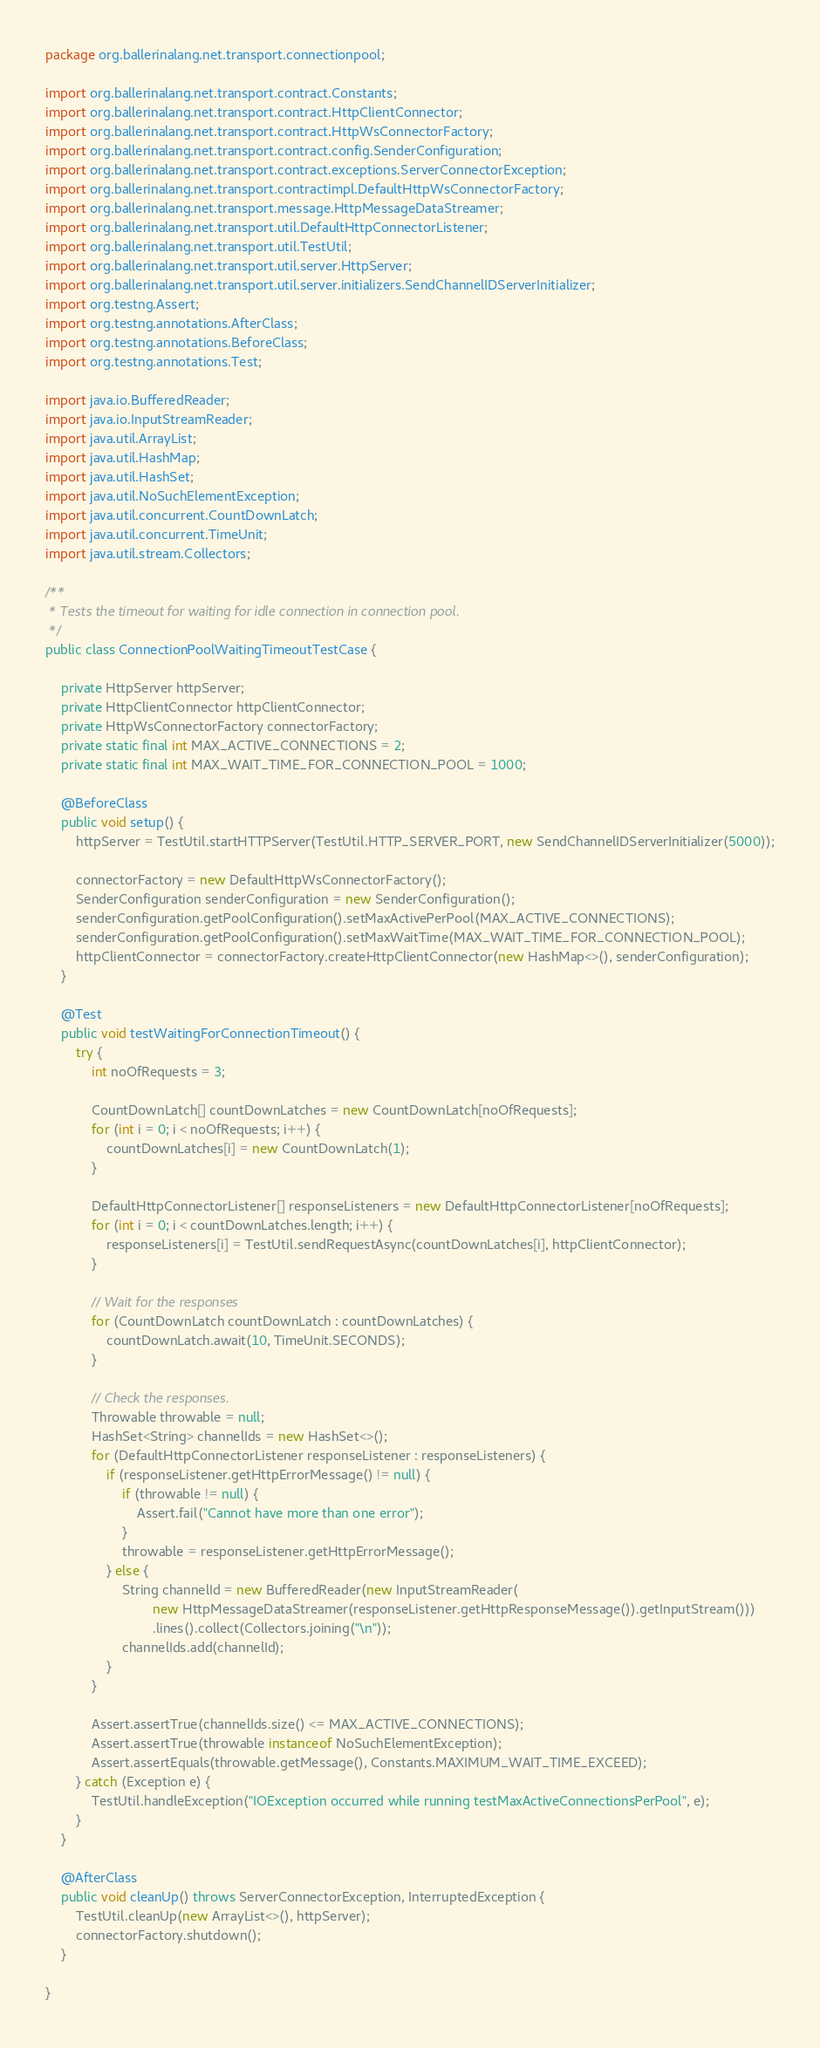Convert code to text. <code><loc_0><loc_0><loc_500><loc_500><_Java_>package org.ballerinalang.net.transport.connectionpool;

import org.ballerinalang.net.transport.contract.Constants;
import org.ballerinalang.net.transport.contract.HttpClientConnector;
import org.ballerinalang.net.transport.contract.HttpWsConnectorFactory;
import org.ballerinalang.net.transport.contract.config.SenderConfiguration;
import org.ballerinalang.net.transport.contract.exceptions.ServerConnectorException;
import org.ballerinalang.net.transport.contractimpl.DefaultHttpWsConnectorFactory;
import org.ballerinalang.net.transport.message.HttpMessageDataStreamer;
import org.ballerinalang.net.transport.util.DefaultHttpConnectorListener;
import org.ballerinalang.net.transport.util.TestUtil;
import org.ballerinalang.net.transport.util.server.HttpServer;
import org.ballerinalang.net.transport.util.server.initializers.SendChannelIDServerInitializer;
import org.testng.Assert;
import org.testng.annotations.AfterClass;
import org.testng.annotations.BeforeClass;
import org.testng.annotations.Test;

import java.io.BufferedReader;
import java.io.InputStreamReader;
import java.util.ArrayList;
import java.util.HashMap;
import java.util.HashSet;
import java.util.NoSuchElementException;
import java.util.concurrent.CountDownLatch;
import java.util.concurrent.TimeUnit;
import java.util.stream.Collectors;

/**
 * Tests the timeout for waiting for idle connection in connection pool.
 */
public class ConnectionPoolWaitingTimeoutTestCase {

    private HttpServer httpServer;
    private HttpClientConnector httpClientConnector;
    private HttpWsConnectorFactory connectorFactory;
    private static final int MAX_ACTIVE_CONNECTIONS = 2;
    private static final int MAX_WAIT_TIME_FOR_CONNECTION_POOL = 1000;

    @BeforeClass
    public void setup() {
        httpServer = TestUtil.startHTTPServer(TestUtil.HTTP_SERVER_PORT, new SendChannelIDServerInitializer(5000));

        connectorFactory = new DefaultHttpWsConnectorFactory();
        SenderConfiguration senderConfiguration = new SenderConfiguration();
        senderConfiguration.getPoolConfiguration().setMaxActivePerPool(MAX_ACTIVE_CONNECTIONS);
        senderConfiguration.getPoolConfiguration().setMaxWaitTime(MAX_WAIT_TIME_FOR_CONNECTION_POOL);
        httpClientConnector = connectorFactory.createHttpClientConnector(new HashMap<>(), senderConfiguration);
    }

    @Test
    public void testWaitingForConnectionTimeout() {
        try {
            int noOfRequests = 3;

            CountDownLatch[] countDownLatches = new CountDownLatch[noOfRequests];
            for (int i = 0; i < noOfRequests; i++) {
                countDownLatches[i] = new CountDownLatch(1);
            }

            DefaultHttpConnectorListener[] responseListeners = new DefaultHttpConnectorListener[noOfRequests];
            for (int i = 0; i < countDownLatches.length; i++) {
                responseListeners[i] = TestUtil.sendRequestAsync(countDownLatches[i], httpClientConnector);
            }

            // Wait for the responses
            for (CountDownLatch countDownLatch : countDownLatches) {
                countDownLatch.await(10, TimeUnit.SECONDS);
            }

            // Check the responses.
            Throwable throwable = null;
            HashSet<String> channelIds = new HashSet<>();
            for (DefaultHttpConnectorListener responseListener : responseListeners) {
                if (responseListener.getHttpErrorMessage() != null) {
                    if (throwable != null) {
                        Assert.fail("Cannot have more than one error");
                    }
                    throwable = responseListener.getHttpErrorMessage();
                } else {
                    String channelId = new BufferedReader(new InputStreamReader(
                            new HttpMessageDataStreamer(responseListener.getHttpResponseMessage()).getInputStream()))
                            .lines().collect(Collectors.joining("\n"));
                    channelIds.add(channelId);
                }
            }

            Assert.assertTrue(channelIds.size() <= MAX_ACTIVE_CONNECTIONS);
            Assert.assertTrue(throwable instanceof NoSuchElementException);
            Assert.assertEquals(throwable.getMessage(), Constants.MAXIMUM_WAIT_TIME_EXCEED);
        } catch (Exception e) {
            TestUtil.handleException("IOException occurred while running testMaxActiveConnectionsPerPool", e);
        }
    }

    @AfterClass
    public void cleanUp() throws ServerConnectorException, InterruptedException {
        TestUtil.cleanUp(new ArrayList<>(), httpServer);
        connectorFactory.shutdown();
    }

}
</code> 